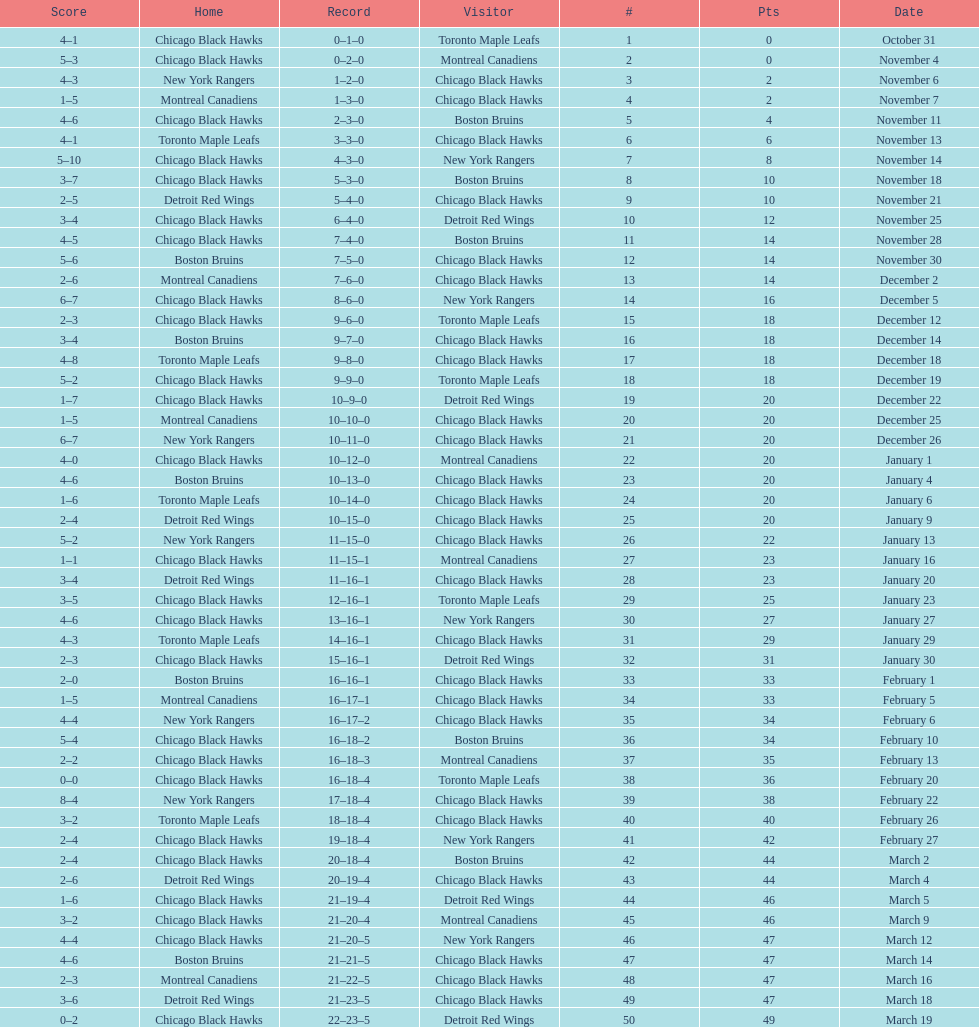What is the difference in pts between december 5th and november 11th? 3. 